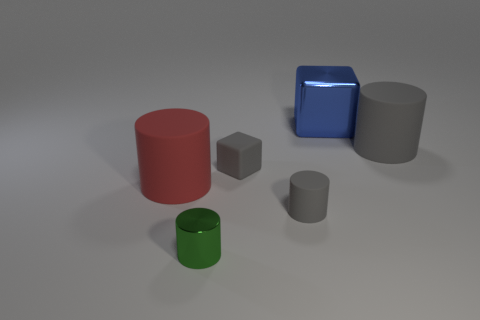Add 3 small rubber cylinders. How many objects exist? 9 Subtract all cylinders. How many objects are left? 2 Subtract all tiny cylinders. Subtract all metallic things. How many objects are left? 2 Add 3 big red objects. How many big red objects are left? 4 Add 1 small metallic objects. How many small metallic objects exist? 2 Subtract 0 red spheres. How many objects are left? 6 